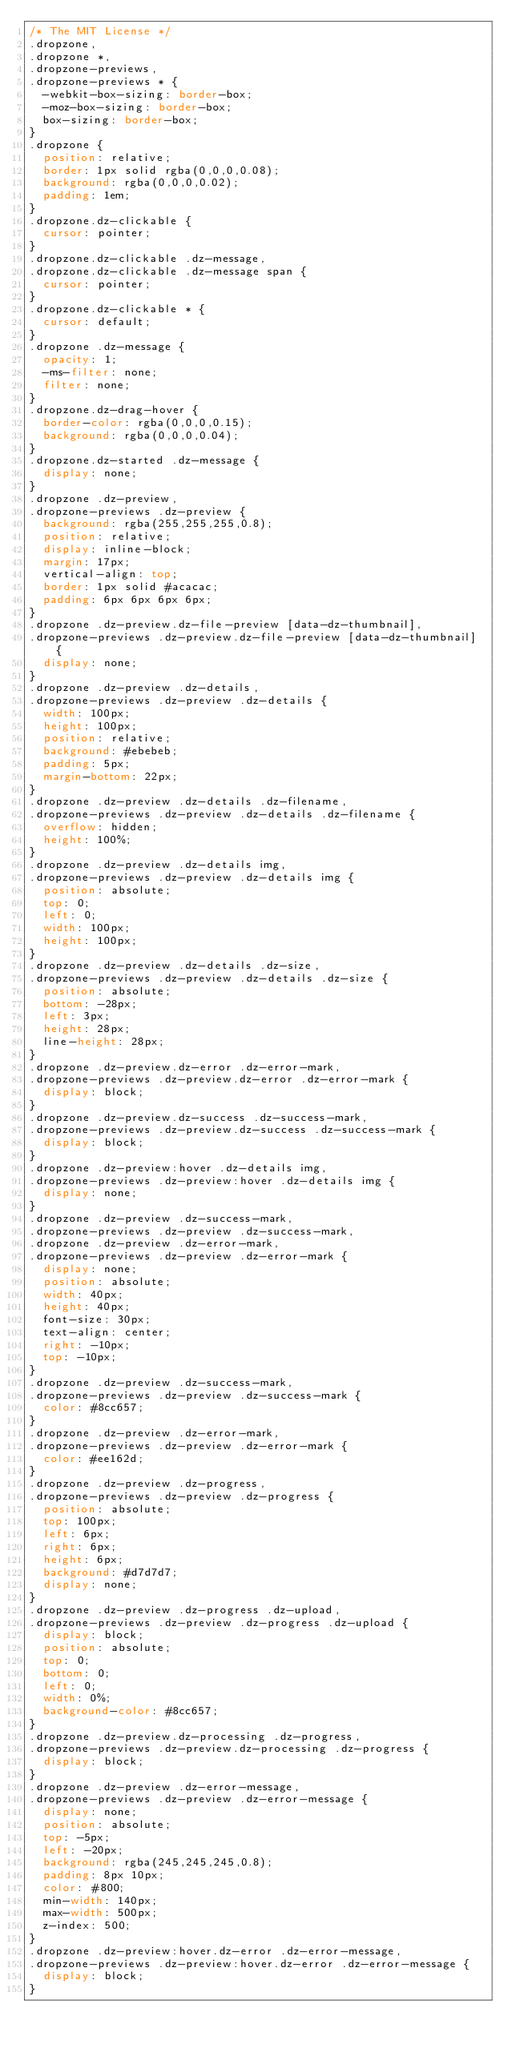Convert code to text. <code><loc_0><loc_0><loc_500><loc_500><_CSS_>/* The MIT License */
.dropzone,
.dropzone *,
.dropzone-previews,
.dropzone-previews * {
  -webkit-box-sizing: border-box;
  -moz-box-sizing: border-box;
  box-sizing: border-box;
}
.dropzone {
  position: relative;
  border: 1px solid rgba(0,0,0,0.08);
  background: rgba(0,0,0,0.02);
  padding: 1em;
}
.dropzone.dz-clickable {
  cursor: pointer;
}
.dropzone.dz-clickable .dz-message,
.dropzone.dz-clickable .dz-message span {
  cursor: pointer;
}
.dropzone.dz-clickable * {
  cursor: default;
}
.dropzone .dz-message {
  opacity: 1;
  -ms-filter: none;
  filter: none;
}
.dropzone.dz-drag-hover {
  border-color: rgba(0,0,0,0.15);
  background: rgba(0,0,0,0.04);
}
.dropzone.dz-started .dz-message {
  display: none;
}
.dropzone .dz-preview,
.dropzone-previews .dz-preview {
  background: rgba(255,255,255,0.8);
  position: relative;
  display: inline-block;
  margin: 17px;
  vertical-align: top;
  border: 1px solid #acacac;
  padding: 6px 6px 6px 6px;
}
.dropzone .dz-preview.dz-file-preview [data-dz-thumbnail],
.dropzone-previews .dz-preview.dz-file-preview [data-dz-thumbnail] {
  display: none;
}
.dropzone .dz-preview .dz-details,
.dropzone-previews .dz-preview .dz-details {
  width: 100px;
  height: 100px;
  position: relative;
  background: #ebebeb;
  padding: 5px;
  margin-bottom: 22px;
}
.dropzone .dz-preview .dz-details .dz-filename,
.dropzone-previews .dz-preview .dz-details .dz-filename {
  overflow: hidden;
  height: 100%;
}
.dropzone .dz-preview .dz-details img,
.dropzone-previews .dz-preview .dz-details img {
  position: absolute;
  top: 0;
  left: 0;
  width: 100px;
  height: 100px;
}
.dropzone .dz-preview .dz-details .dz-size,
.dropzone-previews .dz-preview .dz-details .dz-size {
  position: absolute;
  bottom: -28px;
  left: 3px;
  height: 28px;
  line-height: 28px;
}
.dropzone .dz-preview.dz-error .dz-error-mark,
.dropzone-previews .dz-preview.dz-error .dz-error-mark {
  display: block;
}
.dropzone .dz-preview.dz-success .dz-success-mark,
.dropzone-previews .dz-preview.dz-success .dz-success-mark {
  display: block;
}
.dropzone .dz-preview:hover .dz-details img,
.dropzone-previews .dz-preview:hover .dz-details img {
  display: none;
}
.dropzone .dz-preview .dz-success-mark,
.dropzone-previews .dz-preview .dz-success-mark,
.dropzone .dz-preview .dz-error-mark,
.dropzone-previews .dz-preview .dz-error-mark {
  display: none;
  position: absolute;
  width: 40px;
  height: 40px;
  font-size: 30px;
  text-align: center;
  right: -10px;
  top: -10px;
}
.dropzone .dz-preview .dz-success-mark,
.dropzone-previews .dz-preview .dz-success-mark {
  color: #8cc657;
}
.dropzone .dz-preview .dz-error-mark,
.dropzone-previews .dz-preview .dz-error-mark {
  color: #ee162d;
}
.dropzone .dz-preview .dz-progress,
.dropzone-previews .dz-preview .dz-progress {
  position: absolute;
  top: 100px;
  left: 6px;
  right: 6px;
  height: 6px;
  background: #d7d7d7;
  display: none;
}
.dropzone .dz-preview .dz-progress .dz-upload,
.dropzone-previews .dz-preview .dz-progress .dz-upload {
  display: block;
  position: absolute;
  top: 0;
  bottom: 0;
  left: 0;
  width: 0%;
  background-color: #8cc657;
}
.dropzone .dz-preview.dz-processing .dz-progress,
.dropzone-previews .dz-preview.dz-processing .dz-progress {
  display: block;
}
.dropzone .dz-preview .dz-error-message,
.dropzone-previews .dz-preview .dz-error-message {
  display: none;
  position: absolute;
  top: -5px;
  left: -20px;
  background: rgba(245,245,245,0.8);
  padding: 8px 10px;
  color: #800;
  min-width: 140px;
  max-width: 500px;
  z-index: 500;
}
.dropzone .dz-preview:hover.dz-error .dz-error-message,
.dropzone-previews .dz-preview:hover.dz-error .dz-error-message {
  display: block;
}</code> 